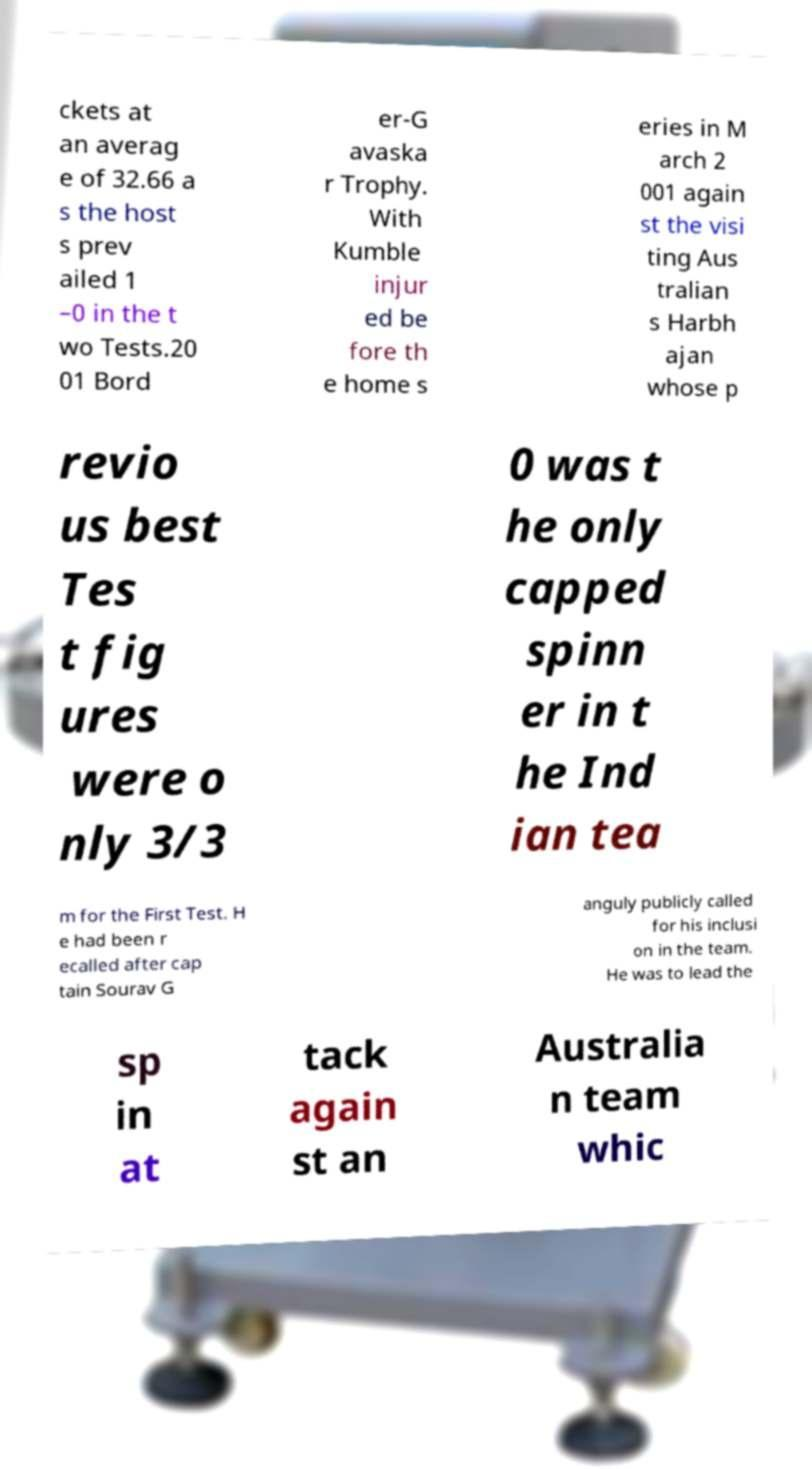Can you read and provide the text displayed in the image?This photo seems to have some interesting text. Can you extract and type it out for me? ckets at an averag e of 32.66 a s the host s prev ailed 1 –0 in the t wo Tests.20 01 Bord er-G avaska r Trophy. With Kumble injur ed be fore th e home s eries in M arch 2 001 again st the visi ting Aus tralian s Harbh ajan whose p revio us best Tes t fig ures were o nly 3/3 0 was t he only capped spinn er in t he Ind ian tea m for the First Test. H e had been r ecalled after cap tain Sourav G anguly publicly called for his inclusi on in the team. He was to lead the sp in at tack again st an Australia n team whic 